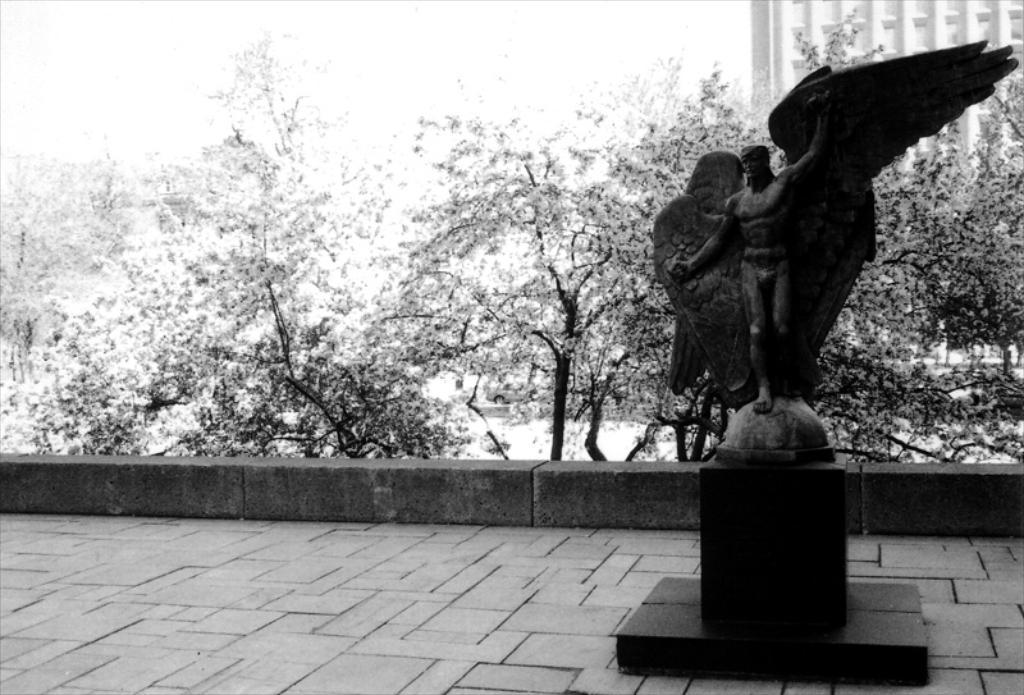How would you summarize this image in a sentence or two? There is a black statue holding wings in his hand and in background there are trees and a building. 